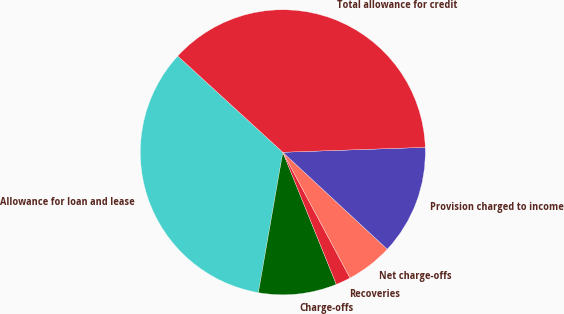Convert chart to OTSL. <chart><loc_0><loc_0><loc_500><loc_500><pie_chart><fcel>Allowance for loan and lease<fcel>Charge-offs<fcel>Recoveries<fcel>Net charge-offs<fcel>Provision charged to income<fcel>Total allowance for credit<nl><fcel>34.06%<fcel>8.87%<fcel>1.69%<fcel>5.28%<fcel>12.46%<fcel>37.65%<nl></chart> 